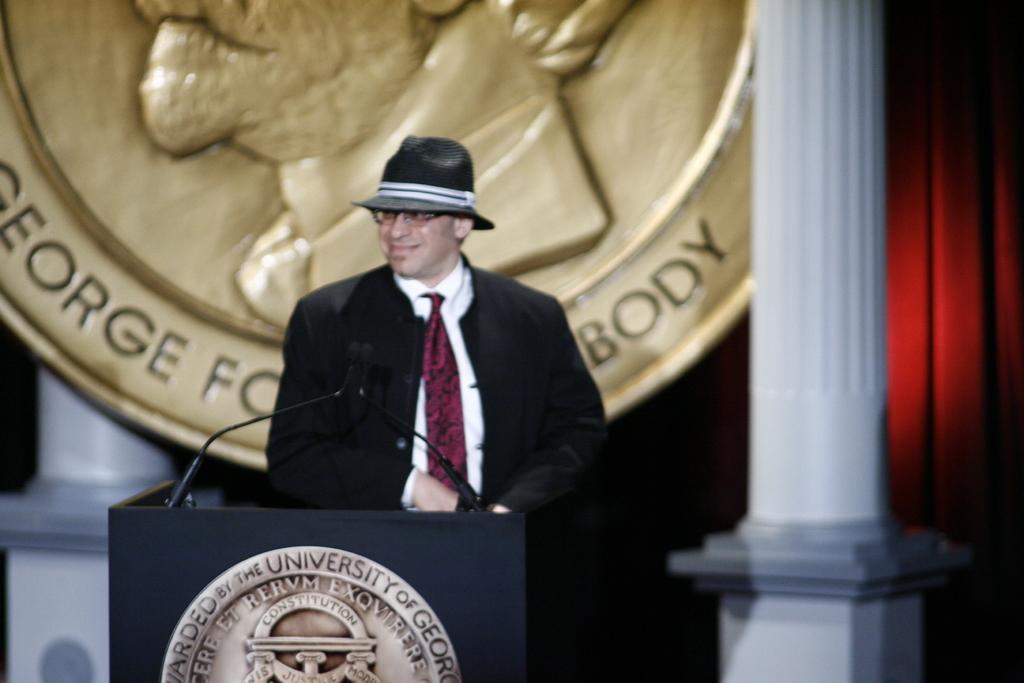In one or two sentences, can you explain what this image depicts? In this picture there is a man standing and smiling and wore hat, in front of him we can see microphones on the podium. In the background of the image we can see pillars, curtain and board. 